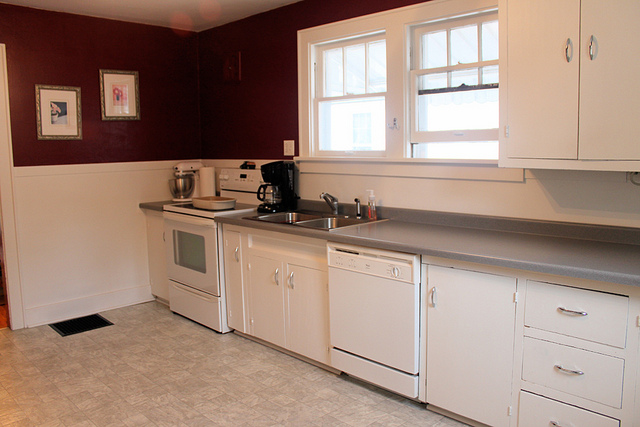Is there any appliance near the sink? Yes, there is a mixer or kitchen tool located near the sink, likely used for food preparation. 